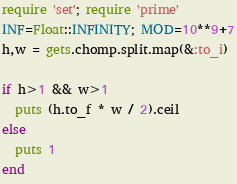<code> <loc_0><loc_0><loc_500><loc_500><_Ruby_>require 'set'; require 'prime'
INF=Float::INFINITY; MOD=10**9+7
h,w = gets.chomp.split.map(&:to_i)

if h>1 && w>1
  puts (h.to_f * w / 2).ceil
else
  puts 1
end</code> 